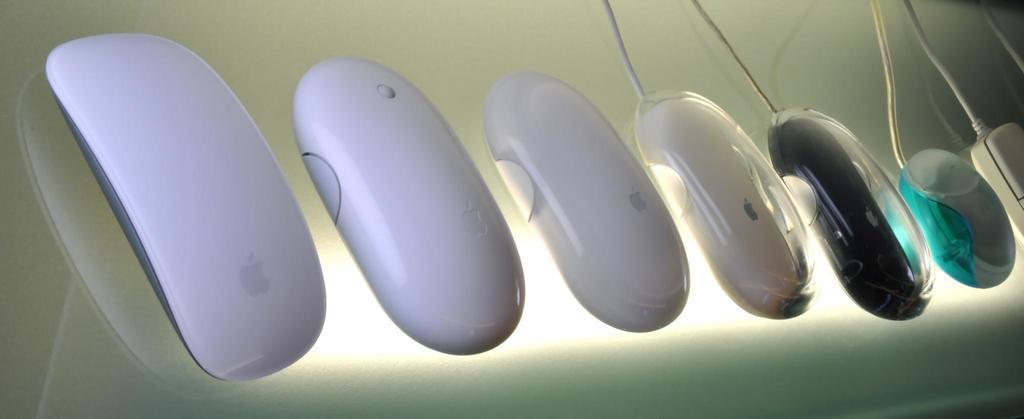Describe this image in one or two sentences. In this image I can see few mouses which are in white, black, green and grey color. These are on the glass surface. I can see the light and the wires. 